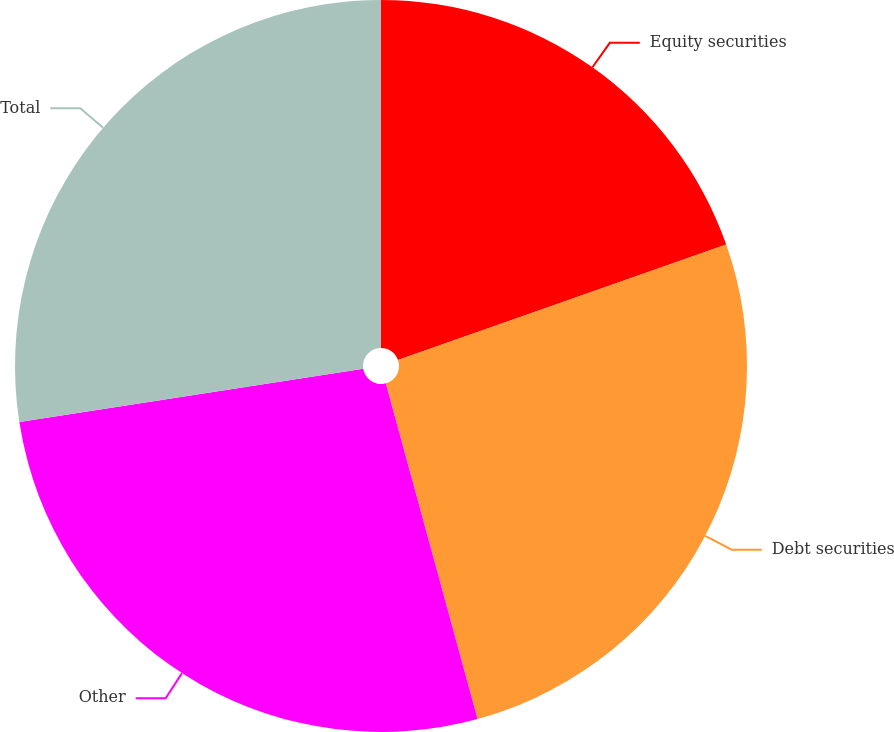<chart> <loc_0><loc_0><loc_500><loc_500><pie_chart><fcel>Equity securities<fcel>Debt securities<fcel>Other<fcel>Total<nl><fcel>19.61%<fcel>26.14%<fcel>26.8%<fcel>27.45%<nl></chart> 